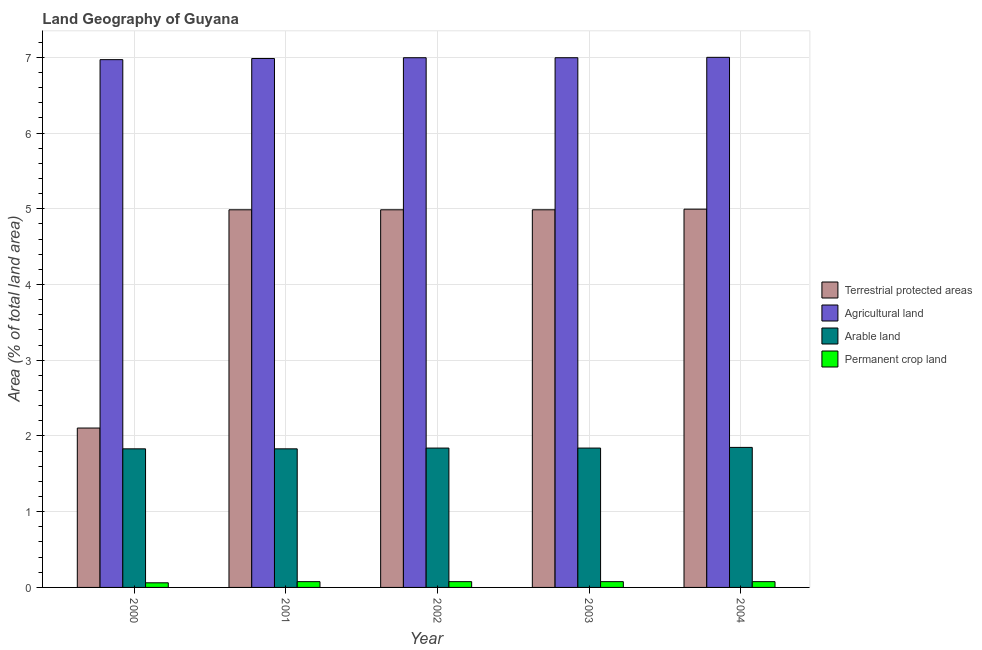Are the number of bars on each tick of the X-axis equal?
Offer a terse response. Yes. How many bars are there on the 2nd tick from the left?
Keep it short and to the point. 4. What is the label of the 2nd group of bars from the left?
Your answer should be compact. 2001. What is the percentage of area under permanent crop land in 2002?
Provide a short and direct response. 0.08. Across all years, what is the maximum percentage of land under terrestrial protection?
Make the answer very short. 5. Across all years, what is the minimum percentage of area under permanent crop land?
Provide a succinct answer. 0.06. In which year was the percentage of area under arable land minimum?
Provide a short and direct response. 2000. What is the total percentage of area under arable land in the graph?
Your answer should be compact. 9.19. What is the difference between the percentage of area under permanent crop land in 2001 and that in 2004?
Ensure brevity in your answer.  5.423222681130713e-5. What is the difference between the percentage of land under terrestrial protection in 2004 and the percentage of area under agricultural land in 2002?
Keep it short and to the point. 0.01. What is the average percentage of land under terrestrial protection per year?
Provide a short and direct response. 4.41. In how many years, is the percentage of area under permanent crop land greater than 3.8 %?
Keep it short and to the point. 0. What is the ratio of the percentage of area under permanent crop land in 2003 to that in 2004?
Offer a terse response. 1. Is the percentage of area under arable land in 2003 less than that in 2004?
Your answer should be very brief. Yes. Is the difference between the percentage of land under terrestrial protection in 2003 and 2004 greater than the difference between the percentage of area under agricultural land in 2003 and 2004?
Your answer should be compact. No. What is the difference between the highest and the second highest percentage of land under terrestrial protection?
Provide a succinct answer. 0.01. What is the difference between the highest and the lowest percentage of land under terrestrial protection?
Make the answer very short. 2.89. Is it the case that in every year, the sum of the percentage of land under terrestrial protection and percentage of area under permanent crop land is greater than the sum of percentage of area under agricultural land and percentage of area under arable land?
Keep it short and to the point. No. What does the 1st bar from the left in 2002 represents?
Offer a terse response. Terrestrial protected areas. What does the 4th bar from the right in 2002 represents?
Give a very brief answer. Terrestrial protected areas. How many bars are there?
Provide a short and direct response. 20. Are all the bars in the graph horizontal?
Offer a terse response. No. What is the difference between two consecutive major ticks on the Y-axis?
Keep it short and to the point. 1. Does the graph contain any zero values?
Make the answer very short. No. Does the graph contain grids?
Your answer should be compact. Yes. How are the legend labels stacked?
Make the answer very short. Vertical. What is the title of the graph?
Your answer should be compact. Land Geography of Guyana. What is the label or title of the Y-axis?
Keep it short and to the point. Area (% of total land area). What is the Area (% of total land area) of Terrestrial protected areas in 2000?
Offer a very short reply. 2.1. What is the Area (% of total land area) in Agricultural land in 2000?
Provide a short and direct response. 6.97. What is the Area (% of total land area) in Arable land in 2000?
Make the answer very short. 1.83. What is the Area (% of total land area) in Permanent crop land in 2000?
Provide a short and direct response. 0.06. What is the Area (% of total land area) in Terrestrial protected areas in 2001?
Make the answer very short. 4.99. What is the Area (% of total land area) in Agricultural land in 2001?
Provide a short and direct response. 6.98. What is the Area (% of total land area) of Arable land in 2001?
Your answer should be very brief. 1.83. What is the Area (% of total land area) in Permanent crop land in 2001?
Give a very brief answer. 0.08. What is the Area (% of total land area) of Terrestrial protected areas in 2002?
Ensure brevity in your answer.  4.99. What is the Area (% of total land area) in Agricultural land in 2002?
Give a very brief answer. 7. What is the Area (% of total land area) in Arable land in 2002?
Keep it short and to the point. 1.84. What is the Area (% of total land area) in Permanent crop land in 2002?
Offer a terse response. 0.08. What is the Area (% of total land area) of Terrestrial protected areas in 2003?
Your answer should be very brief. 4.99. What is the Area (% of total land area) in Agricultural land in 2003?
Give a very brief answer. 7. What is the Area (% of total land area) of Arable land in 2003?
Your response must be concise. 1.84. What is the Area (% of total land area) in Permanent crop land in 2003?
Keep it short and to the point. 0.08. What is the Area (% of total land area) in Terrestrial protected areas in 2004?
Your answer should be very brief. 5. What is the Area (% of total land area) in Agricultural land in 2004?
Your answer should be very brief. 7. What is the Area (% of total land area) of Arable land in 2004?
Make the answer very short. 1.85. What is the Area (% of total land area) of Permanent crop land in 2004?
Provide a succinct answer. 0.08. Across all years, what is the maximum Area (% of total land area) in Terrestrial protected areas?
Your answer should be compact. 5. Across all years, what is the maximum Area (% of total land area) of Agricultural land?
Offer a terse response. 7. Across all years, what is the maximum Area (% of total land area) of Arable land?
Your answer should be very brief. 1.85. Across all years, what is the maximum Area (% of total land area) in Permanent crop land?
Your answer should be compact. 0.08. Across all years, what is the minimum Area (% of total land area) of Terrestrial protected areas?
Offer a very short reply. 2.1. Across all years, what is the minimum Area (% of total land area) in Agricultural land?
Ensure brevity in your answer.  6.97. Across all years, what is the minimum Area (% of total land area) in Arable land?
Offer a terse response. 1.83. Across all years, what is the minimum Area (% of total land area) of Permanent crop land?
Your answer should be very brief. 0.06. What is the total Area (% of total land area) of Terrestrial protected areas in the graph?
Keep it short and to the point. 22.06. What is the total Area (% of total land area) of Agricultural land in the graph?
Provide a short and direct response. 34.94. What is the total Area (% of total land area) in Arable land in the graph?
Offer a very short reply. 9.19. What is the total Area (% of total land area) of Permanent crop land in the graph?
Give a very brief answer. 0.37. What is the difference between the Area (% of total land area) in Terrestrial protected areas in 2000 and that in 2001?
Offer a very short reply. -2.88. What is the difference between the Area (% of total land area) in Agricultural land in 2000 and that in 2001?
Give a very brief answer. -0.02. What is the difference between the Area (% of total land area) in Arable land in 2000 and that in 2001?
Provide a short and direct response. 0. What is the difference between the Area (% of total land area) of Permanent crop land in 2000 and that in 2001?
Your answer should be very brief. -0.02. What is the difference between the Area (% of total land area) in Terrestrial protected areas in 2000 and that in 2002?
Your answer should be compact. -2.88. What is the difference between the Area (% of total land area) in Agricultural land in 2000 and that in 2002?
Your answer should be compact. -0.03. What is the difference between the Area (% of total land area) of Arable land in 2000 and that in 2002?
Make the answer very short. -0.01. What is the difference between the Area (% of total land area) in Permanent crop land in 2000 and that in 2002?
Provide a short and direct response. -0.02. What is the difference between the Area (% of total land area) in Terrestrial protected areas in 2000 and that in 2003?
Offer a terse response. -2.88. What is the difference between the Area (% of total land area) in Agricultural land in 2000 and that in 2003?
Provide a succinct answer. -0.03. What is the difference between the Area (% of total land area) in Arable land in 2000 and that in 2003?
Provide a short and direct response. -0.01. What is the difference between the Area (% of total land area) in Permanent crop land in 2000 and that in 2003?
Offer a very short reply. -0.02. What is the difference between the Area (% of total land area) of Terrestrial protected areas in 2000 and that in 2004?
Your response must be concise. -2.89. What is the difference between the Area (% of total land area) of Agricultural land in 2000 and that in 2004?
Your answer should be very brief. -0.03. What is the difference between the Area (% of total land area) of Arable land in 2000 and that in 2004?
Provide a succinct answer. -0.02. What is the difference between the Area (% of total land area) in Permanent crop land in 2000 and that in 2004?
Keep it short and to the point. -0.02. What is the difference between the Area (% of total land area) in Agricultural land in 2001 and that in 2002?
Offer a terse response. -0.01. What is the difference between the Area (% of total land area) in Arable land in 2001 and that in 2002?
Offer a very short reply. -0.01. What is the difference between the Area (% of total land area) of Permanent crop land in 2001 and that in 2002?
Ensure brevity in your answer.  0. What is the difference between the Area (% of total land area) in Terrestrial protected areas in 2001 and that in 2003?
Provide a short and direct response. 0. What is the difference between the Area (% of total land area) of Agricultural land in 2001 and that in 2003?
Ensure brevity in your answer.  -0.01. What is the difference between the Area (% of total land area) in Arable land in 2001 and that in 2003?
Provide a succinct answer. -0.01. What is the difference between the Area (% of total land area) in Permanent crop land in 2001 and that in 2003?
Your response must be concise. 0. What is the difference between the Area (% of total land area) of Terrestrial protected areas in 2001 and that in 2004?
Provide a short and direct response. -0.01. What is the difference between the Area (% of total land area) of Agricultural land in 2001 and that in 2004?
Give a very brief answer. -0.02. What is the difference between the Area (% of total land area) of Arable land in 2001 and that in 2004?
Your response must be concise. -0.02. What is the difference between the Area (% of total land area) in Agricultural land in 2002 and that in 2003?
Offer a terse response. 0. What is the difference between the Area (% of total land area) in Terrestrial protected areas in 2002 and that in 2004?
Provide a succinct answer. -0.01. What is the difference between the Area (% of total land area) of Agricultural land in 2002 and that in 2004?
Ensure brevity in your answer.  -0.01. What is the difference between the Area (% of total land area) in Arable land in 2002 and that in 2004?
Offer a terse response. -0.01. What is the difference between the Area (% of total land area) in Permanent crop land in 2002 and that in 2004?
Your answer should be very brief. 0. What is the difference between the Area (% of total land area) in Terrestrial protected areas in 2003 and that in 2004?
Your answer should be very brief. -0.01. What is the difference between the Area (% of total land area) of Agricultural land in 2003 and that in 2004?
Your response must be concise. -0.01. What is the difference between the Area (% of total land area) of Arable land in 2003 and that in 2004?
Make the answer very short. -0.01. What is the difference between the Area (% of total land area) in Permanent crop land in 2003 and that in 2004?
Your answer should be compact. 0. What is the difference between the Area (% of total land area) of Terrestrial protected areas in 2000 and the Area (% of total land area) of Agricultural land in 2001?
Give a very brief answer. -4.88. What is the difference between the Area (% of total land area) in Terrestrial protected areas in 2000 and the Area (% of total land area) in Arable land in 2001?
Offer a very short reply. 0.27. What is the difference between the Area (% of total land area) of Terrestrial protected areas in 2000 and the Area (% of total land area) of Permanent crop land in 2001?
Offer a terse response. 2.03. What is the difference between the Area (% of total land area) in Agricultural land in 2000 and the Area (% of total land area) in Arable land in 2001?
Provide a short and direct response. 5.14. What is the difference between the Area (% of total land area) of Agricultural land in 2000 and the Area (% of total land area) of Permanent crop land in 2001?
Provide a short and direct response. 6.89. What is the difference between the Area (% of total land area) of Arable land in 2000 and the Area (% of total land area) of Permanent crop land in 2001?
Ensure brevity in your answer.  1.75. What is the difference between the Area (% of total land area) of Terrestrial protected areas in 2000 and the Area (% of total land area) of Agricultural land in 2002?
Provide a short and direct response. -4.89. What is the difference between the Area (% of total land area) of Terrestrial protected areas in 2000 and the Area (% of total land area) of Arable land in 2002?
Ensure brevity in your answer.  0.26. What is the difference between the Area (% of total land area) in Terrestrial protected areas in 2000 and the Area (% of total land area) in Permanent crop land in 2002?
Offer a terse response. 2.03. What is the difference between the Area (% of total land area) in Agricultural land in 2000 and the Area (% of total land area) in Arable land in 2002?
Provide a succinct answer. 5.13. What is the difference between the Area (% of total land area) of Agricultural land in 2000 and the Area (% of total land area) of Permanent crop land in 2002?
Give a very brief answer. 6.89. What is the difference between the Area (% of total land area) of Arable land in 2000 and the Area (% of total land area) of Permanent crop land in 2002?
Your response must be concise. 1.75. What is the difference between the Area (% of total land area) of Terrestrial protected areas in 2000 and the Area (% of total land area) of Agricultural land in 2003?
Offer a terse response. -4.89. What is the difference between the Area (% of total land area) in Terrestrial protected areas in 2000 and the Area (% of total land area) in Arable land in 2003?
Provide a short and direct response. 0.26. What is the difference between the Area (% of total land area) of Terrestrial protected areas in 2000 and the Area (% of total land area) of Permanent crop land in 2003?
Give a very brief answer. 2.03. What is the difference between the Area (% of total land area) of Agricultural land in 2000 and the Area (% of total land area) of Arable land in 2003?
Provide a short and direct response. 5.13. What is the difference between the Area (% of total land area) of Agricultural land in 2000 and the Area (% of total land area) of Permanent crop land in 2003?
Your answer should be very brief. 6.89. What is the difference between the Area (% of total land area) of Arable land in 2000 and the Area (% of total land area) of Permanent crop land in 2003?
Provide a succinct answer. 1.75. What is the difference between the Area (% of total land area) of Terrestrial protected areas in 2000 and the Area (% of total land area) of Agricultural land in 2004?
Give a very brief answer. -4.9. What is the difference between the Area (% of total land area) in Terrestrial protected areas in 2000 and the Area (% of total land area) in Arable land in 2004?
Keep it short and to the point. 0.26. What is the difference between the Area (% of total land area) in Terrestrial protected areas in 2000 and the Area (% of total land area) in Permanent crop land in 2004?
Your answer should be very brief. 2.03. What is the difference between the Area (% of total land area) in Agricultural land in 2000 and the Area (% of total land area) in Arable land in 2004?
Your answer should be very brief. 5.12. What is the difference between the Area (% of total land area) in Agricultural land in 2000 and the Area (% of total land area) in Permanent crop land in 2004?
Your answer should be compact. 6.89. What is the difference between the Area (% of total land area) in Arable land in 2000 and the Area (% of total land area) in Permanent crop land in 2004?
Offer a very short reply. 1.75. What is the difference between the Area (% of total land area) in Terrestrial protected areas in 2001 and the Area (% of total land area) in Agricultural land in 2002?
Keep it short and to the point. -2.01. What is the difference between the Area (% of total land area) of Terrestrial protected areas in 2001 and the Area (% of total land area) of Arable land in 2002?
Provide a short and direct response. 3.15. What is the difference between the Area (% of total land area) of Terrestrial protected areas in 2001 and the Area (% of total land area) of Permanent crop land in 2002?
Ensure brevity in your answer.  4.91. What is the difference between the Area (% of total land area) in Agricultural land in 2001 and the Area (% of total land area) in Arable land in 2002?
Offer a very short reply. 5.14. What is the difference between the Area (% of total land area) of Agricultural land in 2001 and the Area (% of total land area) of Permanent crop land in 2002?
Give a very brief answer. 6.91. What is the difference between the Area (% of total land area) in Arable land in 2001 and the Area (% of total land area) in Permanent crop land in 2002?
Offer a terse response. 1.75. What is the difference between the Area (% of total land area) in Terrestrial protected areas in 2001 and the Area (% of total land area) in Agricultural land in 2003?
Provide a succinct answer. -2.01. What is the difference between the Area (% of total land area) of Terrestrial protected areas in 2001 and the Area (% of total land area) of Arable land in 2003?
Your response must be concise. 3.15. What is the difference between the Area (% of total land area) in Terrestrial protected areas in 2001 and the Area (% of total land area) in Permanent crop land in 2003?
Make the answer very short. 4.91. What is the difference between the Area (% of total land area) of Agricultural land in 2001 and the Area (% of total land area) of Arable land in 2003?
Offer a very short reply. 5.14. What is the difference between the Area (% of total land area) in Agricultural land in 2001 and the Area (% of total land area) in Permanent crop land in 2003?
Provide a succinct answer. 6.91. What is the difference between the Area (% of total land area) in Arable land in 2001 and the Area (% of total land area) in Permanent crop land in 2003?
Make the answer very short. 1.75. What is the difference between the Area (% of total land area) of Terrestrial protected areas in 2001 and the Area (% of total land area) of Agricultural land in 2004?
Offer a terse response. -2.01. What is the difference between the Area (% of total land area) in Terrestrial protected areas in 2001 and the Area (% of total land area) in Arable land in 2004?
Keep it short and to the point. 3.14. What is the difference between the Area (% of total land area) of Terrestrial protected areas in 2001 and the Area (% of total land area) of Permanent crop land in 2004?
Provide a short and direct response. 4.91. What is the difference between the Area (% of total land area) in Agricultural land in 2001 and the Area (% of total land area) in Arable land in 2004?
Provide a succinct answer. 5.14. What is the difference between the Area (% of total land area) in Agricultural land in 2001 and the Area (% of total land area) in Permanent crop land in 2004?
Offer a terse response. 6.91. What is the difference between the Area (% of total land area) of Arable land in 2001 and the Area (% of total land area) of Permanent crop land in 2004?
Your answer should be very brief. 1.75. What is the difference between the Area (% of total land area) in Terrestrial protected areas in 2002 and the Area (% of total land area) in Agricultural land in 2003?
Your response must be concise. -2.01. What is the difference between the Area (% of total land area) in Terrestrial protected areas in 2002 and the Area (% of total land area) in Arable land in 2003?
Your answer should be compact. 3.15. What is the difference between the Area (% of total land area) in Terrestrial protected areas in 2002 and the Area (% of total land area) in Permanent crop land in 2003?
Offer a very short reply. 4.91. What is the difference between the Area (% of total land area) of Agricultural land in 2002 and the Area (% of total land area) of Arable land in 2003?
Make the answer very short. 5.15. What is the difference between the Area (% of total land area) of Agricultural land in 2002 and the Area (% of total land area) of Permanent crop land in 2003?
Make the answer very short. 6.92. What is the difference between the Area (% of total land area) of Arable land in 2002 and the Area (% of total land area) of Permanent crop land in 2003?
Your response must be concise. 1.76. What is the difference between the Area (% of total land area) of Terrestrial protected areas in 2002 and the Area (% of total land area) of Agricultural land in 2004?
Your response must be concise. -2.01. What is the difference between the Area (% of total land area) of Terrestrial protected areas in 2002 and the Area (% of total land area) of Arable land in 2004?
Provide a short and direct response. 3.14. What is the difference between the Area (% of total land area) in Terrestrial protected areas in 2002 and the Area (% of total land area) in Permanent crop land in 2004?
Offer a very short reply. 4.91. What is the difference between the Area (% of total land area) in Agricultural land in 2002 and the Area (% of total land area) in Arable land in 2004?
Your answer should be very brief. 5.15. What is the difference between the Area (% of total land area) of Agricultural land in 2002 and the Area (% of total land area) of Permanent crop land in 2004?
Your answer should be compact. 6.92. What is the difference between the Area (% of total land area) in Arable land in 2002 and the Area (% of total land area) in Permanent crop land in 2004?
Keep it short and to the point. 1.76. What is the difference between the Area (% of total land area) of Terrestrial protected areas in 2003 and the Area (% of total land area) of Agricultural land in 2004?
Make the answer very short. -2.01. What is the difference between the Area (% of total land area) in Terrestrial protected areas in 2003 and the Area (% of total land area) in Arable land in 2004?
Make the answer very short. 3.14. What is the difference between the Area (% of total land area) of Terrestrial protected areas in 2003 and the Area (% of total land area) of Permanent crop land in 2004?
Provide a short and direct response. 4.91. What is the difference between the Area (% of total land area) in Agricultural land in 2003 and the Area (% of total land area) in Arable land in 2004?
Provide a short and direct response. 5.15. What is the difference between the Area (% of total land area) of Agricultural land in 2003 and the Area (% of total land area) of Permanent crop land in 2004?
Keep it short and to the point. 6.92. What is the difference between the Area (% of total land area) of Arable land in 2003 and the Area (% of total land area) of Permanent crop land in 2004?
Your answer should be very brief. 1.76. What is the average Area (% of total land area) in Terrestrial protected areas per year?
Make the answer very short. 4.41. What is the average Area (% of total land area) of Agricultural land per year?
Provide a short and direct response. 6.99. What is the average Area (% of total land area) of Arable land per year?
Make the answer very short. 1.84. What is the average Area (% of total land area) in Permanent crop land per year?
Provide a short and direct response. 0.07. In the year 2000, what is the difference between the Area (% of total land area) in Terrestrial protected areas and Area (% of total land area) in Agricultural land?
Provide a short and direct response. -4.86. In the year 2000, what is the difference between the Area (% of total land area) in Terrestrial protected areas and Area (% of total land area) in Arable land?
Provide a short and direct response. 0.27. In the year 2000, what is the difference between the Area (% of total land area) of Terrestrial protected areas and Area (% of total land area) of Permanent crop land?
Offer a terse response. 2.04. In the year 2000, what is the difference between the Area (% of total land area) in Agricultural land and Area (% of total land area) in Arable land?
Provide a succinct answer. 5.14. In the year 2000, what is the difference between the Area (% of total land area) of Agricultural land and Area (% of total land area) of Permanent crop land?
Provide a short and direct response. 6.91. In the year 2000, what is the difference between the Area (% of total land area) in Arable land and Area (% of total land area) in Permanent crop land?
Ensure brevity in your answer.  1.77. In the year 2001, what is the difference between the Area (% of total land area) in Terrestrial protected areas and Area (% of total land area) in Agricultural land?
Your answer should be very brief. -2. In the year 2001, what is the difference between the Area (% of total land area) of Terrestrial protected areas and Area (% of total land area) of Arable land?
Your answer should be very brief. 3.16. In the year 2001, what is the difference between the Area (% of total land area) of Terrestrial protected areas and Area (% of total land area) of Permanent crop land?
Offer a very short reply. 4.91. In the year 2001, what is the difference between the Area (% of total land area) in Agricultural land and Area (% of total land area) in Arable land?
Give a very brief answer. 5.15. In the year 2001, what is the difference between the Area (% of total land area) of Agricultural land and Area (% of total land area) of Permanent crop land?
Provide a succinct answer. 6.91. In the year 2001, what is the difference between the Area (% of total land area) of Arable land and Area (% of total land area) of Permanent crop land?
Ensure brevity in your answer.  1.75. In the year 2002, what is the difference between the Area (% of total land area) in Terrestrial protected areas and Area (% of total land area) in Agricultural land?
Your response must be concise. -2.01. In the year 2002, what is the difference between the Area (% of total land area) of Terrestrial protected areas and Area (% of total land area) of Arable land?
Offer a very short reply. 3.15. In the year 2002, what is the difference between the Area (% of total land area) of Terrestrial protected areas and Area (% of total land area) of Permanent crop land?
Your answer should be very brief. 4.91. In the year 2002, what is the difference between the Area (% of total land area) in Agricultural land and Area (% of total land area) in Arable land?
Ensure brevity in your answer.  5.15. In the year 2002, what is the difference between the Area (% of total land area) of Agricultural land and Area (% of total land area) of Permanent crop land?
Provide a short and direct response. 6.92. In the year 2002, what is the difference between the Area (% of total land area) in Arable land and Area (% of total land area) in Permanent crop land?
Make the answer very short. 1.76. In the year 2003, what is the difference between the Area (% of total land area) in Terrestrial protected areas and Area (% of total land area) in Agricultural land?
Offer a terse response. -2.01. In the year 2003, what is the difference between the Area (% of total land area) in Terrestrial protected areas and Area (% of total land area) in Arable land?
Make the answer very short. 3.15. In the year 2003, what is the difference between the Area (% of total land area) of Terrestrial protected areas and Area (% of total land area) of Permanent crop land?
Keep it short and to the point. 4.91. In the year 2003, what is the difference between the Area (% of total land area) of Agricultural land and Area (% of total land area) of Arable land?
Keep it short and to the point. 5.15. In the year 2003, what is the difference between the Area (% of total land area) of Agricultural land and Area (% of total land area) of Permanent crop land?
Give a very brief answer. 6.92. In the year 2003, what is the difference between the Area (% of total land area) in Arable land and Area (% of total land area) in Permanent crop land?
Your answer should be compact. 1.76. In the year 2004, what is the difference between the Area (% of total land area) of Terrestrial protected areas and Area (% of total land area) of Agricultural land?
Give a very brief answer. -2.01. In the year 2004, what is the difference between the Area (% of total land area) in Terrestrial protected areas and Area (% of total land area) in Arable land?
Your answer should be very brief. 3.15. In the year 2004, what is the difference between the Area (% of total land area) in Terrestrial protected areas and Area (% of total land area) in Permanent crop land?
Your answer should be very brief. 4.92. In the year 2004, what is the difference between the Area (% of total land area) of Agricultural land and Area (% of total land area) of Arable land?
Give a very brief answer. 5.15. In the year 2004, what is the difference between the Area (% of total land area) of Agricultural land and Area (% of total land area) of Permanent crop land?
Offer a terse response. 6.92. In the year 2004, what is the difference between the Area (% of total land area) in Arable land and Area (% of total land area) in Permanent crop land?
Ensure brevity in your answer.  1.77. What is the ratio of the Area (% of total land area) of Terrestrial protected areas in 2000 to that in 2001?
Provide a short and direct response. 0.42. What is the ratio of the Area (% of total land area) of Arable land in 2000 to that in 2001?
Give a very brief answer. 1. What is the ratio of the Area (% of total land area) in Permanent crop land in 2000 to that in 2001?
Keep it short and to the point. 0.8. What is the ratio of the Area (% of total land area) of Terrestrial protected areas in 2000 to that in 2002?
Give a very brief answer. 0.42. What is the ratio of the Area (% of total land area) in Agricultural land in 2000 to that in 2002?
Provide a short and direct response. 1. What is the ratio of the Area (% of total land area) in Arable land in 2000 to that in 2002?
Make the answer very short. 0.99. What is the ratio of the Area (% of total land area) in Permanent crop land in 2000 to that in 2002?
Keep it short and to the point. 0.8. What is the ratio of the Area (% of total land area) in Terrestrial protected areas in 2000 to that in 2003?
Offer a very short reply. 0.42. What is the ratio of the Area (% of total land area) of Agricultural land in 2000 to that in 2003?
Provide a short and direct response. 1. What is the ratio of the Area (% of total land area) in Arable land in 2000 to that in 2003?
Provide a short and direct response. 0.99. What is the ratio of the Area (% of total land area) of Terrestrial protected areas in 2000 to that in 2004?
Your answer should be compact. 0.42. What is the ratio of the Area (% of total land area) in Agricultural land in 2000 to that in 2004?
Provide a short and direct response. 1. What is the ratio of the Area (% of total land area) of Arable land in 2000 to that in 2004?
Ensure brevity in your answer.  0.99. What is the ratio of the Area (% of total land area) of Permanent crop land in 2000 to that in 2004?
Provide a succinct answer. 0.8. What is the ratio of the Area (% of total land area) in Agricultural land in 2001 to that in 2002?
Offer a terse response. 1. What is the ratio of the Area (% of total land area) of Terrestrial protected areas in 2001 to that in 2003?
Your answer should be very brief. 1. What is the ratio of the Area (% of total land area) of Arable land in 2001 to that in 2003?
Ensure brevity in your answer.  0.99. What is the ratio of the Area (% of total land area) of Terrestrial protected areas in 2002 to that in 2003?
Offer a terse response. 1. What is the ratio of the Area (% of total land area) of Permanent crop land in 2002 to that in 2003?
Your response must be concise. 1. What is the ratio of the Area (% of total land area) in Agricultural land in 2002 to that in 2004?
Provide a short and direct response. 1. What is the ratio of the Area (% of total land area) in Agricultural land in 2003 to that in 2004?
Your response must be concise. 1. What is the ratio of the Area (% of total land area) in Arable land in 2003 to that in 2004?
Provide a short and direct response. 1. What is the difference between the highest and the second highest Area (% of total land area) in Terrestrial protected areas?
Ensure brevity in your answer.  0.01. What is the difference between the highest and the second highest Area (% of total land area) of Agricultural land?
Your answer should be very brief. 0.01. What is the difference between the highest and the second highest Area (% of total land area) in Arable land?
Offer a very short reply. 0.01. What is the difference between the highest and the second highest Area (% of total land area) in Permanent crop land?
Make the answer very short. 0. What is the difference between the highest and the lowest Area (% of total land area) of Terrestrial protected areas?
Keep it short and to the point. 2.89. What is the difference between the highest and the lowest Area (% of total land area) in Agricultural land?
Offer a terse response. 0.03. What is the difference between the highest and the lowest Area (% of total land area) in Arable land?
Give a very brief answer. 0.02. What is the difference between the highest and the lowest Area (% of total land area) in Permanent crop land?
Provide a succinct answer. 0.02. 